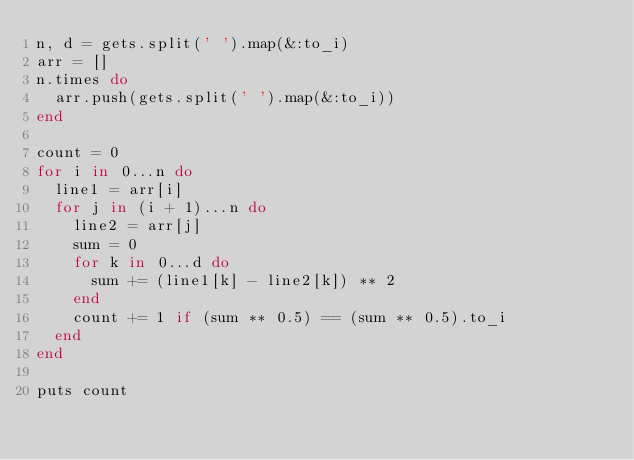Convert code to text. <code><loc_0><loc_0><loc_500><loc_500><_Ruby_>n, d = gets.split(' ').map(&:to_i)
arr = []
n.times do
  arr.push(gets.split(' ').map(&:to_i))
end

count = 0
for i in 0...n do
  line1 = arr[i]
  for j in (i + 1)...n do
    line2 = arr[j]
    sum = 0
    for k in 0...d do
      sum += (line1[k] - line2[k]) ** 2
    end
    count += 1 if (sum ** 0.5) == (sum ** 0.5).to_i
  end
end

puts count</code> 